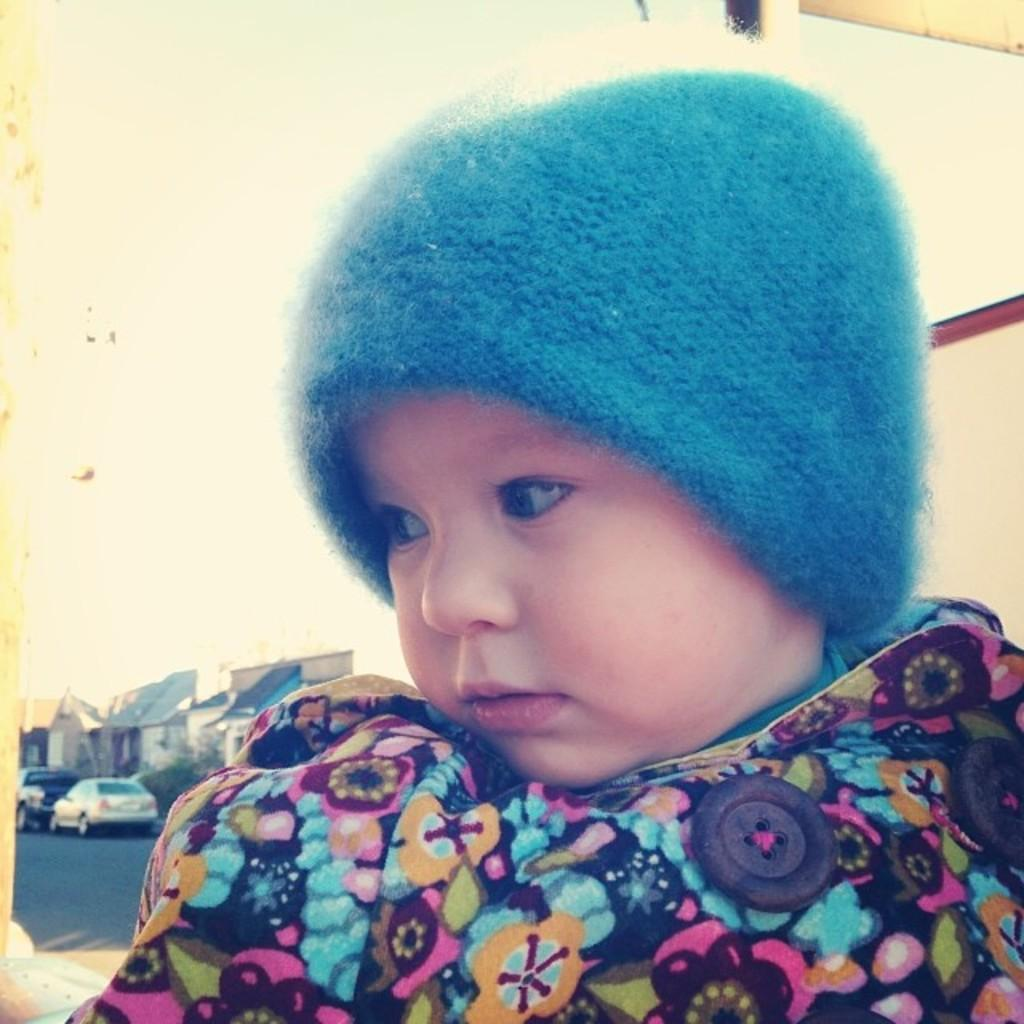What is the main subject of the image? There is a kid in the image. What can be seen in the background of the image? There are houses, cars, a road, and the sky visible in the background of the image. What type of oatmeal is being served on the point in the image? There is no oatmeal or point present in the image. 